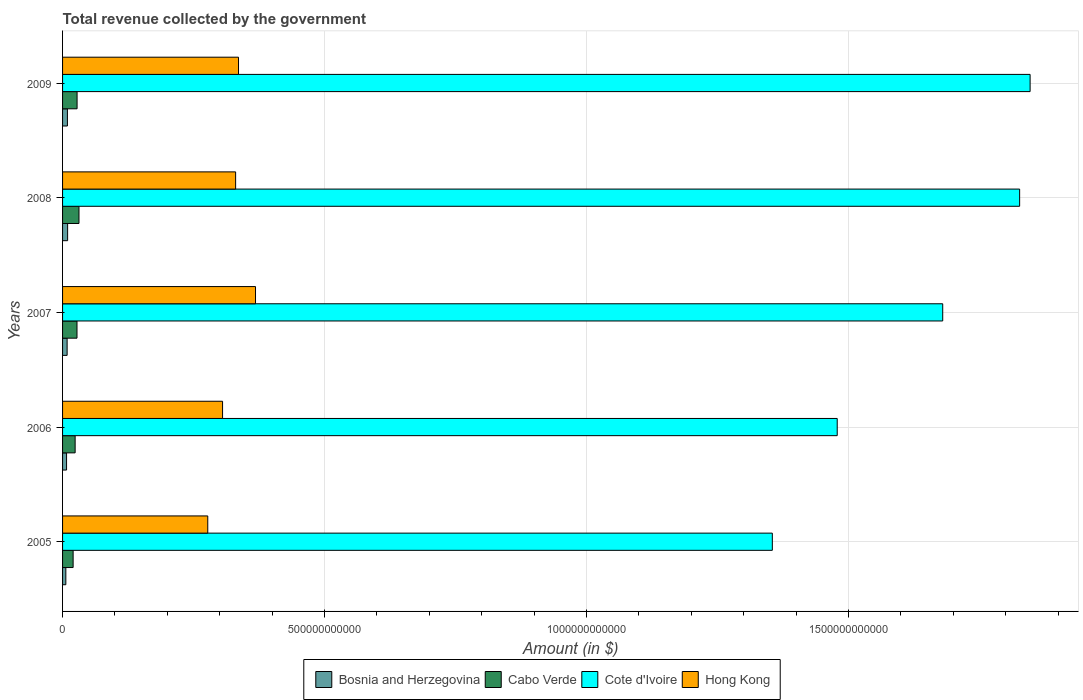How many groups of bars are there?
Provide a short and direct response. 5. Are the number of bars per tick equal to the number of legend labels?
Offer a terse response. Yes. In how many cases, is the number of bars for a given year not equal to the number of legend labels?
Make the answer very short. 0. What is the total revenue collected by the government in Cabo Verde in 2007?
Ensure brevity in your answer.  2.75e+1. Across all years, what is the maximum total revenue collected by the government in Bosnia and Herzegovina?
Offer a terse response. 9.67e+09. Across all years, what is the minimum total revenue collected by the government in Cote d'Ivoire?
Your response must be concise. 1.35e+12. What is the total total revenue collected by the government in Hong Kong in the graph?
Your response must be concise. 1.62e+12. What is the difference between the total revenue collected by the government in Cote d'Ivoire in 2007 and that in 2008?
Your answer should be very brief. -1.47e+11. What is the difference between the total revenue collected by the government in Hong Kong in 2006 and the total revenue collected by the government in Cabo Verde in 2005?
Keep it short and to the point. 2.85e+11. What is the average total revenue collected by the government in Cabo Verde per year?
Make the answer very short. 2.61e+1. In the year 2007, what is the difference between the total revenue collected by the government in Bosnia and Herzegovina and total revenue collected by the government in Hong Kong?
Provide a short and direct response. -3.60e+11. In how many years, is the total revenue collected by the government in Bosnia and Herzegovina greater than 1400000000000 $?
Your answer should be compact. 0. What is the ratio of the total revenue collected by the government in Hong Kong in 2005 to that in 2008?
Your response must be concise. 0.84. What is the difference between the highest and the second highest total revenue collected by the government in Cote d'Ivoire?
Offer a very short reply. 2.00e+1. What is the difference between the highest and the lowest total revenue collected by the government in Bosnia and Herzegovina?
Your answer should be compact. 3.40e+09. Is the sum of the total revenue collected by the government in Cabo Verde in 2006 and 2009 greater than the maximum total revenue collected by the government in Bosnia and Herzegovina across all years?
Give a very brief answer. Yes. What does the 2nd bar from the top in 2005 represents?
Your answer should be compact. Cote d'Ivoire. What does the 3rd bar from the bottom in 2007 represents?
Ensure brevity in your answer.  Cote d'Ivoire. Is it the case that in every year, the sum of the total revenue collected by the government in Cabo Verde and total revenue collected by the government in Bosnia and Herzegovina is greater than the total revenue collected by the government in Hong Kong?
Ensure brevity in your answer.  No. How many bars are there?
Offer a very short reply. 20. What is the difference between two consecutive major ticks on the X-axis?
Keep it short and to the point. 5.00e+11. Does the graph contain any zero values?
Offer a terse response. No. Where does the legend appear in the graph?
Your response must be concise. Bottom center. What is the title of the graph?
Offer a terse response. Total revenue collected by the government. What is the label or title of the X-axis?
Provide a succinct answer. Amount (in $). What is the Amount (in $) in Bosnia and Herzegovina in 2005?
Your response must be concise. 6.27e+09. What is the Amount (in $) of Cabo Verde in 2005?
Ensure brevity in your answer.  2.02e+1. What is the Amount (in $) of Cote d'Ivoire in 2005?
Offer a terse response. 1.35e+12. What is the Amount (in $) of Hong Kong in 2005?
Give a very brief answer. 2.77e+11. What is the Amount (in $) of Bosnia and Herzegovina in 2006?
Keep it short and to the point. 7.62e+09. What is the Amount (in $) in Cabo Verde in 2006?
Offer a terse response. 2.40e+1. What is the Amount (in $) in Cote d'Ivoire in 2006?
Offer a terse response. 1.48e+12. What is the Amount (in $) of Hong Kong in 2006?
Your answer should be very brief. 3.05e+11. What is the Amount (in $) in Bosnia and Herzegovina in 2007?
Your response must be concise. 8.71e+09. What is the Amount (in $) of Cabo Verde in 2007?
Your answer should be very brief. 2.75e+1. What is the Amount (in $) of Cote d'Ivoire in 2007?
Your answer should be very brief. 1.68e+12. What is the Amount (in $) in Hong Kong in 2007?
Make the answer very short. 3.68e+11. What is the Amount (in $) of Bosnia and Herzegovina in 2008?
Provide a short and direct response. 9.67e+09. What is the Amount (in $) of Cabo Verde in 2008?
Provide a short and direct response. 3.13e+1. What is the Amount (in $) in Cote d'Ivoire in 2008?
Your response must be concise. 1.83e+12. What is the Amount (in $) in Hong Kong in 2008?
Give a very brief answer. 3.30e+11. What is the Amount (in $) of Bosnia and Herzegovina in 2009?
Ensure brevity in your answer.  9.26e+09. What is the Amount (in $) in Cabo Verde in 2009?
Provide a short and direct response. 2.77e+1. What is the Amount (in $) in Cote d'Ivoire in 2009?
Provide a short and direct response. 1.85e+12. What is the Amount (in $) of Hong Kong in 2009?
Your answer should be very brief. 3.36e+11. Across all years, what is the maximum Amount (in $) of Bosnia and Herzegovina?
Your answer should be very brief. 9.67e+09. Across all years, what is the maximum Amount (in $) of Cabo Verde?
Your answer should be compact. 3.13e+1. Across all years, what is the maximum Amount (in $) in Cote d'Ivoire?
Make the answer very short. 1.85e+12. Across all years, what is the maximum Amount (in $) in Hong Kong?
Ensure brevity in your answer.  3.68e+11. Across all years, what is the minimum Amount (in $) of Bosnia and Herzegovina?
Ensure brevity in your answer.  6.27e+09. Across all years, what is the minimum Amount (in $) of Cabo Verde?
Provide a succinct answer. 2.02e+1. Across all years, what is the minimum Amount (in $) in Cote d'Ivoire?
Offer a very short reply. 1.35e+12. Across all years, what is the minimum Amount (in $) in Hong Kong?
Provide a short and direct response. 2.77e+11. What is the total Amount (in $) in Bosnia and Herzegovina in the graph?
Provide a short and direct response. 4.15e+1. What is the total Amount (in $) of Cabo Verde in the graph?
Give a very brief answer. 1.31e+11. What is the total Amount (in $) in Cote d'Ivoire in the graph?
Keep it short and to the point. 8.19e+12. What is the total Amount (in $) of Hong Kong in the graph?
Your response must be concise. 1.62e+12. What is the difference between the Amount (in $) of Bosnia and Herzegovina in 2005 and that in 2006?
Your response must be concise. -1.36e+09. What is the difference between the Amount (in $) of Cabo Verde in 2005 and that in 2006?
Your answer should be very brief. -3.85e+09. What is the difference between the Amount (in $) in Cote d'Ivoire in 2005 and that in 2006?
Offer a terse response. -1.24e+11. What is the difference between the Amount (in $) in Hong Kong in 2005 and that in 2006?
Provide a succinct answer. -2.82e+1. What is the difference between the Amount (in $) of Bosnia and Herzegovina in 2005 and that in 2007?
Provide a short and direct response. -2.44e+09. What is the difference between the Amount (in $) of Cabo Verde in 2005 and that in 2007?
Your answer should be very brief. -7.39e+09. What is the difference between the Amount (in $) of Cote d'Ivoire in 2005 and that in 2007?
Your response must be concise. -3.25e+11. What is the difference between the Amount (in $) of Hong Kong in 2005 and that in 2007?
Your answer should be very brief. -9.11e+1. What is the difference between the Amount (in $) of Bosnia and Herzegovina in 2005 and that in 2008?
Ensure brevity in your answer.  -3.40e+09. What is the difference between the Amount (in $) in Cabo Verde in 2005 and that in 2008?
Your response must be concise. -1.12e+1. What is the difference between the Amount (in $) of Cote d'Ivoire in 2005 and that in 2008?
Your answer should be very brief. -4.72e+11. What is the difference between the Amount (in $) in Hong Kong in 2005 and that in 2008?
Your answer should be very brief. -5.32e+1. What is the difference between the Amount (in $) of Bosnia and Herzegovina in 2005 and that in 2009?
Provide a succinct answer. -3.00e+09. What is the difference between the Amount (in $) of Cabo Verde in 2005 and that in 2009?
Your answer should be very brief. -7.54e+09. What is the difference between the Amount (in $) in Cote d'Ivoire in 2005 and that in 2009?
Offer a terse response. -4.92e+11. What is the difference between the Amount (in $) in Hong Kong in 2005 and that in 2009?
Make the answer very short. -5.87e+1. What is the difference between the Amount (in $) in Bosnia and Herzegovina in 2006 and that in 2007?
Give a very brief answer. -1.09e+09. What is the difference between the Amount (in $) of Cabo Verde in 2006 and that in 2007?
Ensure brevity in your answer.  -3.54e+09. What is the difference between the Amount (in $) in Cote d'Ivoire in 2006 and that in 2007?
Your response must be concise. -2.01e+11. What is the difference between the Amount (in $) in Hong Kong in 2006 and that in 2007?
Give a very brief answer. -6.29e+1. What is the difference between the Amount (in $) in Bosnia and Herzegovina in 2006 and that in 2008?
Provide a succinct answer. -2.04e+09. What is the difference between the Amount (in $) of Cabo Verde in 2006 and that in 2008?
Provide a succinct answer. -7.32e+09. What is the difference between the Amount (in $) of Cote d'Ivoire in 2006 and that in 2008?
Your answer should be compact. -3.48e+11. What is the difference between the Amount (in $) of Hong Kong in 2006 and that in 2008?
Ensure brevity in your answer.  -2.49e+1. What is the difference between the Amount (in $) of Bosnia and Herzegovina in 2006 and that in 2009?
Your answer should be very brief. -1.64e+09. What is the difference between the Amount (in $) in Cabo Verde in 2006 and that in 2009?
Your answer should be very brief. -3.69e+09. What is the difference between the Amount (in $) in Cote d'Ivoire in 2006 and that in 2009?
Keep it short and to the point. -3.68e+11. What is the difference between the Amount (in $) of Hong Kong in 2006 and that in 2009?
Ensure brevity in your answer.  -3.04e+1. What is the difference between the Amount (in $) in Bosnia and Herzegovina in 2007 and that in 2008?
Provide a succinct answer. -9.56e+08. What is the difference between the Amount (in $) in Cabo Verde in 2007 and that in 2008?
Provide a short and direct response. -3.78e+09. What is the difference between the Amount (in $) in Cote d'Ivoire in 2007 and that in 2008?
Ensure brevity in your answer.  -1.47e+11. What is the difference between the Amount (in $) of Hong Kong in 2007 and that in 2008?
Make the answer very short. 3.80e+1. What is the difference between the Amount (in $) in Bosnia and Herzegovina in 2007 and that in 2009?
Make the answer very short. -5.53e+08. What is the difference between the Amount (in $) of Cabo Verde in 2007 and that in 2009?
Offer a terse response. -1.49e+08. What is the difference between the Amount (in $) in Cote d'Ivoire in 2007 and that in 2009?
Offer a terse response. -1.67e+11. What is the difference between the Amount (in $) in Hong Kong in 2007 and that in 2009?
Your response must be concise. 3.24e+1. What is the difference between the Amount (in $) in Bosnia and Herzegovina in 2008 and that in 2009?
Give a very brief answer. 4.02e+08. What is the difference between the Amount (in $) in Cabo Verde in 2008 and that in 2009?
Give a very brief answer. 3.63e+09. What is the difference between the Amount (in $) in Cote d'Ivoire in 2008 and that in 2009?
Offer a terse response. -2.00e+1. What is the difference between the Amount (in $) of Hong Kong in 2008 and that in 2009?
Offer a very short reply. -5.50e+09. What is the difference between the Amount (in $) in Bosnia and Herzegovina in 2005 and the Amount (in $) in Cabo Verde in 2006?
Your answer should be compact. -1.77e+1. What is the difference between the Amount (in $) of Bosnia and Herzegovina in 2005 and the Amount (in $) of Cote d'Ivoire in 2006?
Offer a terse response. -1.47e+12. What is the difference between the Amount (in $) in Bosnia and Herzegovina in 2005 and the Amount (in $) in Hong Kong in 2006?
Your response must be concise. -2.99e+11. What is the difference between the Amount (in $) in Cabo Verde in 2005 and the Amount (in $) in Cote d'Ivoire in 2006?
Your response must be concise. -1.46e+12. What is the difference between the Amount (in $) of Cabo Verde in 2005 and the Amount (in $) of Hong Kong in 2006?
Offer a terse response. -2.85e+11. What is the difference between the Amount (in $) in Cote d'Ivoire in 2005 and the Amount (in $) in Hong Kong in 2006?
Give a very brief answer. 1.05e+12. What is the difference between the Amount (in $) of Bosnia and Herzegovina in 2005 and the Amount (in $) of Cabo Verde in 2007?
Provide a short and direct response. -2.13e+1. What is the difference between the Amount (in $) of Bosnia and Herzegovina in 2005 and the Amount (in $) of Cote d'Ivoire in 2007?
Your answer should be very brief. -1.67e+12. What is the difference between the Amount (in $) in Bosnia and Herzegovina in 2005 and the Amount (in $) in Hong Kong in 2007?
Your answer should be very brief. -3.62e+11. What is the difference between the Amount (in $) in Cabo Verde in 2005 and the Amount (in $) in Cote d'Ivoire in 2007?
Your response must be concise. -1.66e+12. What is the difference between the Amount (in $) of Cabo Verde in 2005 and the Amount (in $) of Hong Kong in 2007?
Ensure brevity in your answer.  -3.48e+11. What is the difference between the Amount (in $) in Cote d'Ivoire in 2005 and the Amount (in $) in Hong Kong in 2007?
Give a very brief answer. 9.86e+11. What is the difference between the Amount (in $) of Bosnia and Herzegovina in 2005 and the Amount (in $) of Cabo Verde in 2008?
Offer a very short reply. -2.51e+1. What is the difference between the Amount (in $) of Bosnia and Herzegovina in 2005 and the Amount (in $) of Cote d'Ivoire in 2008?
Your answer should be compact. -1.82e+12. What is the difference between the Amount (in $) of Bosnia and Herzegovina in 2005 and the Amount (in $) of Hong Kong in 2008?
Your answer should be compact. -3.24e+11. What is the difference between the Amount (in $) in Cabo Verde in 2005 and the Amount (in $) in Cote d'Ivoire in 2008?
Provide a short and direct response. -1.81e+12. What is the difference between the Amount (in $) in Cabo Verde in 2005 and the Amount (in $) in Hong Kong in 2008?
Your answer should be compact. -3.10e+11. What is the difference between the Amount (in $) in Cote d'Ivoire in 2005 and the Amount (in $) in Hong Kong in 2008?
Your answer should be very brief. 1.02e+12. What is the difference between the Amount (in $) of Bosnia and Herzegovina in 2005 and the Amount (in $) of Cabo Verde in 2009?
Your answer should be compact. -2.14e+1. What is the difference between the Amount (in $) in Bosnia and Herzegovina in 2005 and the Amount (in $) in Cote d'Ivoire in 2009?
Give a very brief answer. -1.84e+12. What is the difference between the Amount (in $) of Bosnia and Herzegovina in 2005 and the Amount (in $) of Hong Kong in 2009?
Provide a succinct answer. -3.30e+11. What is the difference between the Amount (in $) of Cabo Verde in 2005 and the Amount (in $) of Cote d'Ivoire in 2009?
Make the answer very short. -1.83e+12. What is the difference between the Amount (in $) of Cabo Verde in 2005 and the Amount (in $) of Hong Kong in 2009?
Provide a short and direct response. -3.16e+11. What is the difference between the Amount (in $) in Cote d'Ivoire in 2005 and the Amount (in $) in Hong Kong in 2009?
Your answer should be very brief. 1.02e+12. What is the difference between the Amount (in $) in Bosnia and Herzegovina in 2006 and the Amount (in $) in Cabo Verde in 2007?
Provide a succinct answer. -1.99e+1. What is the difference between the Amount (in $) in Bosnia and Herzegovina in 2006 and the Amount (in $) in Cote d'Ivoire in 2007?
Offer a very short reply. -1.67e+12. What is the difference between the Amount (in $) of Bosnia and Herzegovina in 2006 and the Amount (in $) of Hong Kong in 2007?
Offer a very short reply. -3.61e+11. What is the difference between the Amount (in $) of Cabo Verde in 2006 and the Amount (in $) of Cote d'Ivoire in 2007?
Keep it short and to the point. -1.66e+12. What is the difference between the Amount (in $) of Cabo Verde in 2006 and the Amount (in $) of Hong Kong in 2007?
Your answer should be very brief. -3.44e+11. What is the difference between the Amount (in $) in Cote d'Ivoire in 2006 and the Amount (in $) in Hong Kong in 2007?
Give a very brief answer. 1.11e+12. What is the difference between the Amount (in $) in Bosnia and Herzegovina in 2006 and the Amount (in $) in Cabo Verde in 2008?
Offer a very short reply. -2.37e+1. What is the difference between the Amount (in $) in Bosnia and Herzegovina in 2006 and the Amount (in $) in Cote d'Ivoire in 2008?
Provide a short and direct response. -1.82e+12. What is the difference between the Amount (in $) in Bosnia and Herzegovina in 2006 and the Amount (in $) in Hong Kong in 2008?
Make the answer very short. -3.23e+11. What is the difference between the Amount (in $) in Cabo Verde in 2006 and the Amount (in $) in Cote d'Ivoire in 2008?
Provide a succinct answer. -1.80e+12. What is the difference between the Amount (in $) in Cabo Verde in 2006 and the Amount (in $) in Hong Kong in 2008?
Provide a short and direct response. -3.06e+11. What is the difference between the Amount (in $) in Cote d'Ivoire in 2006 and the Amount (in $) in Hong Kong in 2008?
Your response must be concise. 1.15e+12. What is the difference between the Amount (in $) in Bosnia and Herzegovina in 2006 and the Amount (in $) in Cabo Verde in 2009?
Keep it short and to the point. -2.01e+1. What is the difference between the Amount (in $) in Bosnia and Herzegovina in 2006 and the Amount (in $) in Cote d'Ivoire in 2009?
Your answer should be compact. -1.84e+12. What is the difference between the Amount (in $) of Bosnia and Herzegovina in 2006 and the Amount (in $) of Hong Kong in 2009?
Offer a terse response. -3.28e+11. What is the difference between the Amount (in $) in Cabo Verde in 2006 and the Amount (in $) in Cote d'Ivoire in 2009?
Your answer should be very brief. -1.82e+12. What is the difference between the Amount (in $) of Cabo Verde in 2006 and the Amount (in $) of Hong Kong in 2009?
Your response must be concise. -3.12e+11. What is the difference between the Amount (in $) of Cote d'Ivoire in 2006 and the Amount (in $) of Hong Kong in 2009?
Offer a terse response. 1.14e+12. What is the difference between the Amount (in $) of Bosnia and Herzegovina in 2007 and the Amount (in $) of Cabo Verde in 2008?
Offer a terse response. -2.26e+1. What is the difference between the Amount (in $) in Bosnia and Herzegovina in 2007 and the Amount (in $) in Cote d'Ivoire in 2008?
Offer a very short reply. -1.82e+12. What is the difference between the Amount (in $) of Bosnia and Herzegovina in 2007 and the Amount (in $) of Hong Kong in 2008?
Make the answer very short. -3.22e+11. What is the difference between the Amount (in $) of Cabo Verde in 2007 and the Amount (in $) of Cote d'Ivoire in 2008?
Give a very brief answer. -1.80e+12. What is the difference between the Amount (in $) in Cabo Verde in 2007 and the Amount (in $) in Hong Kong in 2008?
Make the answer very short. -3.03e+11. What is the difference between the Amount (in $) of Cote d'Ivoire in 2007 and the Amount (in $) of Hong Kong in 2008?
Your answer should be compact. 1.35e+12. What is the difference between the Amount (in $) in Bosnia and Herzegovina in 2007 and the Amount (in $) in Cabo Verde in 2009?
Your answer should be compact. -1.90e+1. What is the difference between the Amount (in $) of Bosnia and Herzegovina in 2007 and the Amount (in $) of Cote d'Ivoire in 2009?
Keep it short and to the point. -1.84e+12. What is the difference between the Amount (in $) of Bosnia and Herzegovina in 2007 and the Amount (in $) of Hong Kong in 2009?
Give a very brief answer. -3.27e+11. What is the difference between the Amount (in $) of Cabo Verde in 2007 and the Amount (in $) of Cote d'Ivoire in 2009?
Provide a succinct answer. -1.82e+12. What is the difference between the Amount (in $) in Cabo Verde in 2007 and the Amount (in $) in Hong Kong in 2009?
Make the answer very short. -3.08e+11. What is the difference between the Amount (in $) of Cote d'Ivoire in 2007 and the Amount (in $) of Hong Kong in 2009?
Your answer should be very brief. 1.34e+12. What is the difference between the Amount (in $) of Bosnia and Herzegovina in 2008 and the Amount (in $) of Cabo Verde in 2009?
Your answer should be compact. -1.80e+1. What is the difference between the Amount (in $) in Bosnia and Herzegovina in 2008 and the Amount (in $) in Cote d'Ivoire in 2009?
Provide a succinct answer. -1.84e+12. What is the difference between the Amount (in $) of Bosnia and Herzegovina in 2008 and the Amount (in $) of Hong Kong in 2009?
Keep it short and to the point. -3.26e+11. What is the difference between the Amount (in $) of Cabo Verde in 2008 and the Amount (in $) of Cote d'Ivoire in 2009?
Offer a very short reply. -1.82e+12. What is the difference between the Amount (in $) in Cabo Verde in 2008 and the Amount (in $) in Hong Kong in 2009?
Provide a succinct answer. -3.04e+11. What is the difference between the Amount (in $) in Cote d'Ivoire in 2008 and the Amount (in $) in Hong Kong in 2009?
Offer a terse response. 1.49e+12. What is the average Amount (in $) in Bosnia and Herzegovina per year?
Make the answer very short. 8.31e+09. What is the average Amount (in $) of Cabo Verde per year?
Give a very brief answer. 2.61e+1. What is the average Amount (in $) in Cote d'Ivoire per year?
Make the answer very short. 1.64e+12. What is the average Amount (in $) of Hong Kong per year?
Your answer should be very brief. 3.23e+11. In the year 2005, what is the difference between the Amount (in $) of Bosnia and Herzegovina and Amount (in $) of Cabo Verde?
Give a very brief answer. -1.39e+1. In the year 2005, what is the difference between the Amount (in $) of Bosnia and Herzegovina and Amount (in $) of Cote d'Ivoire?
Your response must be concise. -1.35e+12. In the year 2005, what is the difference between the Amount (in $) of Bosnia and Herzegovina and Amount (in $) of Hong Kong?
Ensure brevity in your answer.  -2.71e+11. In the year 2005, what is the difference between the Amount (in $) of Cabo Verde and Amount (in $) of Cote d'Ivoire?
Keep it short and to the point. -1.33e+12. In the year 2005, what is the difference between the Amount (in $) of Cabo Verde and Amount (in $) of Hong Kong?
Provide a succinct answer. -2.57e+11. In the year 2005, what is the difference between the Amount (in $) of Cote d'Ivoire and Amount (in $) of Hong Kong?
Provide a succinct answer. 1.08e+12. In the year 2006, what is the difference between the Amount (in $) in Bosnia and Herzegovina and Amount (in $) in Cabo Verde?
Make the answer very short. -1.64e+1. In the year 2006, what is the difference between the Amount (in $) of Bosnia and Herzegovina and Amount (in $) of Cote d'Ivoire?
Offer a very short reply. -1.47e+12. In the year 2006, what is the difference between the Amount (in $) in Bosnia and Herzegovina and Amount (in $) in Hong Kong?
Offer a terse response. -2.98e+11. In the year 2006, what is the difference between the Amount (in $) of Cabo Verde and Amount (in $) of Cote d'Ivoire?
Ensure brevity in your answer.  -1.45e+12. In the year 2006, what is the difference between the Amount (in $) in Cabo Verde and Amount (in $) in Hong Kong?
Give a very brief answer. -2.81e+11. In the year 2006, what is the difference between the Amount (in $) in Cote d'Ivoire and Amount (in $) in Hong Kong?
Provide a short and direct response. 1.17e+12. In the year 2007, what is the difference between the Amount (in $) of Bosnia and Herzegovina and Amount (in $) of Cabo Verde?
Give a very brief answer. -1.88e+1. In the year 2007, what is the difference between the Amount (in $) of Bosnia and Herzegovina and Amount (in $) of Cote d'Ivoire?
Provide a short and direct response. -1.67e+12. In the year 2007, what is the difference between the Amount (in $) of Bosnia and Herzegovina and Amount (in $) of Hong Kong?
Offer a very short reply. -3.60e+11. In the year 2007, what is the difference between the Amount (in $) in Cabo Verde and Amount (in $) in Cote d'Ivoire?
Give a very brief answer. -1.65e+12. In the year 2007, what is the difference between the Amount (in $) in Cabo Verde and Amount (in $) in Hong Kong?
Make the answer very short. -3.41e+11. In the year 2007, what is the difference between the Amount (in $) of Cote d'Ivoire and Amount (in $) of Hong Kong?
Give a very brief answer. 1.31e+12. In the year 2008, what is the difference between the Amount (in $) in Bosnia and Herzegovina and Amount (in $) in Cabo Verde?
Offer a very short reply. -2.17e+1. In the year 2008, what is the difference between the Amount (in $) of Bosnia and Herzegovina and Amount (in $) of Cote d'Ivoire?
Provide a succinct answer. -1.82e+12. In the year 2008, what is the difference between the Amount (in $) in Bosnia and Herzegovina and Amount (in $) in Hong Kong?
Your answer should be very brief. -3.21e+11. In the year 2008, what is the difference between the Amount (in $) in Cabo Verde and Amount (in $) in Cote d'Ivoire?
Your answer should be compact. -1.80e+12. In the year 2008, what is the difference between the Amount (in $) in Cabo Verde and Amount (in $) in Hong Kong?
Ensure brevity in your answer.  -2.99e+11. In the year 2008, what is the difference between the Amount (in $) of Cote d'Ivoire and Amount (in $) of Hong Kong?
Your answer should be very brief. 1.50e+12. In the year 2009, what is the difference between the Amount (in $) in Bosnia and Herzegovina and Amount (in $) in Cabo Verde?
Provide a succinct answer. -1.84e+1. In the year 2009, what is the difference between the Amount (in $) in Bosnia and Herzegovina and Amount (in $) in Cote d'Ivoire?
Offer a very short reply. -1.84e+12. In the year 2009, what is the difference between the Amount (in $) of Bosnia and Herzegovina and Amount (in $) of Hong Kong?
Provide a short and direct response. -3.27e+11. In the year 2009, what is the difference between the Amount (in $) in Cabo Verde and Amount (in $) in Cote d'Ivoire?
Give a very brief answer. -1.82e+12. In the year 2009, what is the difference between the Amount (in $) in Cabo Verde and Amount (in $) in Hong Kong?
Provide a short and direct response. -3.08e+11. In the year 2009, what is the difference between the Amount (in $) in Cote d'Ivoire and Amount (in $) in Hong Kong?
Ensure brevity in your answer.  1.51e+12. What is the ratio of the Amount (in $) in Bosnia and Herzegovina in 2005 to that in 2006?
Make the answer very short. 0.82. What is the ratio of the Amount (in $) in Cabo Verde in 2005 to that in 2006?
Your response must be concise. 0.84. What is the ratio of the Amount (in $) of Cote d'Ivoire in 2005 to that in 2006?
Your answer should be very brief. 0.92. What is the ratio of the Amount (in $) of Hong Kong in 2005 to that in 2006?
Give a very brief answer. 0.91. What is the ratio of the Amount (in $) in Bosnia and Herzegovina in 2005 to that in 2007?
Your answer should be very brief. 0.72. What is the ratio of the Amount (in $) of Cabo Verde in 2005 to that in 2007?
Offer a terse response. 0.73. What is the ratio of the Amount (in $) in Cote d'Ivoire in 2005 to that in 2007?
Offer a terse response. 0.81. What is the ratio of the Amount (in $) in Hong Kong in 2005 to that in 2007?
Provide a succinct answer. 0.75. What is the ratio of the Amount (in $) in Bosnia and Herzegovina in 2005 to that in 2008?
Ensure brevity in your answer.  0.65. What is the ratio of the Amount (in $) of Cabo Verde in 2005 to that in 2008?
Your answer should be compact. 0.64. What is the ratio of the Amount (in $) in Cote d'Ivoire in 2005 to that in 2008?
Your response must be concise. 0.74. What is the ratio of the Amount (in $) of Hong Kong in 2005 to that in 2008?
Provide a succinct answer. 0.84. What is the ratio of the Amount (in $) in Bosnia and Herzegovina in 2005 to that in 2009?
Your response must be concise. 0.68. What is the ratio of the Amount (in $) of Cabo Verde in 2005 to that in 2009?
Provide a short and direct response. 0.73. What is the ratio of the Amount (in $) of Cote d'Ivoire in 2005 to that in 2009?
Your answer should be very brief. 0.73. What is the ratio of the Amount (in $) of Hong Kong in 2005 to that in 2009?
Give a very brief answer. 0.83. What is the ratio of the Amount (in $) of Bosnia and Herzegovina in 2006 to that in 2007?
Your answer should be compact. 0.88. What is the ratio of the Amount (in $) of Cabo Verde in 2006 to that in 2007?
Offer a terse response. 0.87. What is the ratio of the Amount (in $) in Cote d'Ivoire in 2006 to that in 2007?
Make the answer very short. 0.88. What is the ratio of the Amount (in $) of Hong Kong in 2006 to that in 2007?
Offer a very short reply. 0.83. What is the ratio of the Amount (in $) in Bosnia and Herzegovina in 2006 to that in 2008?
Offer a terse response. 0.79. What is the ratio of the Amount (in $) in Cabo Verde in 2006 to that in 2008?
Keep it short and to the point. 0.77. What is the ratio of the Amount (in $) of Cote d'Ivoire in 2006 to that in 2008?
Provide a succinct answer. 0.81. What is the ratio of the Amount (in $) in Hong Kong in 2006 to that in 2008?
Give a very brief answer. 0.92. What is the ratio of the Amount (in $) of Bosnia and Herzegovina in 2006 to that in 2009?
Keep it short and to the point. 0.82. What is the ratio of the Amount (in $) of Cabo Verde in 2006 to that in 2009?
Your answer should be very brief. 0.87. What is the ratio of the Amount (in $) in Cote d'Ivoire in 2006 to that in 2009?
Offer a very short reply. 0.8. What is the ratio of the Amount (in $) of Hong Kong in 2006 to that in 2009?
Offer a terse response. 0.91. What is the ratio of the Amount (in $) in Bosnia and Herzegovina in 2007 to that in 2008?
Provide a short and direct response. 0.9. What is the ratio of the Amount (in $) in Cabo Verde in 2007 to that in 2008?
Give a very brief answer. 0.88. What is the ratio of the Amount (in $) of Cote d'Ivoire in 2007 to that in 2008?
Your answer should be very brief. 0.92. What is the ratio of the Amount (in $) of Hong Kong in 2007 to that in 2008?
Your answer should be compact. 1.11. What is the ratio of the Amount (in $) of Bosnia and Herzegovina in 2007 to that in 2009?
Offer a very short reply. 0.94. What is the ratio of the Amount (in $) in Cote d'Ivoire in 2007 to that in 2009?
Provide a succinct answer. 0.91. What is the ratio of the Amount (in $) in Hong Kong in 2007 to that in 2009?
Make the answer very short. 1.1. What is the ratio of the Amount (in $) in Bosnia and Herzegovina in 2008 to that in 2009?
Provide a short and direct response. 1.04. What is the ratio of the Amount (in $) of Cabo Verde in 2008 to that in 2009?
Make the answer very short. 1.13. What is the ratio of the Amount (in $) in Hong Kong in 2008 to that in 2009?
Ensure brevity in your answer.  0.98. What is the difference between the highest and the second highest Amount (in $) in Bosnia and Herzegovina?
Make the answer very short. 4.02e+08. What is the difference between the highest and the second highest Amount (in $) in Cabo Verde?
Ensure brevity in your answer.  3.63e+09. What is the difference between the highest and the second highest Amount (in $) in Cote d'Ivoire?
Offer a terse response. 2.00e+1. What is the difference between the highest and the second highest Amount (in $) of Hong Kong?
Provide a succinct answer. 3.24e+1. What is the difference between the highest and the lowest Amount (in $) of Bosnia and Herzegovina?
Provide a succinct answer. 3.40e+09. What is the difference between the highest and the lowest Amount (in $) of Cabo Verde?
Keep it short and to the point. 1.12e+1. What is the difference between the highest and the lowest Amount (in $) in Cote d'Ivoire?
Your answer should be very brief. 4.92e+11. What is the difference between the highest and the lowest Amount (in $) in Hong Kong?
Keep it short and to the point. 9.11e+1. 